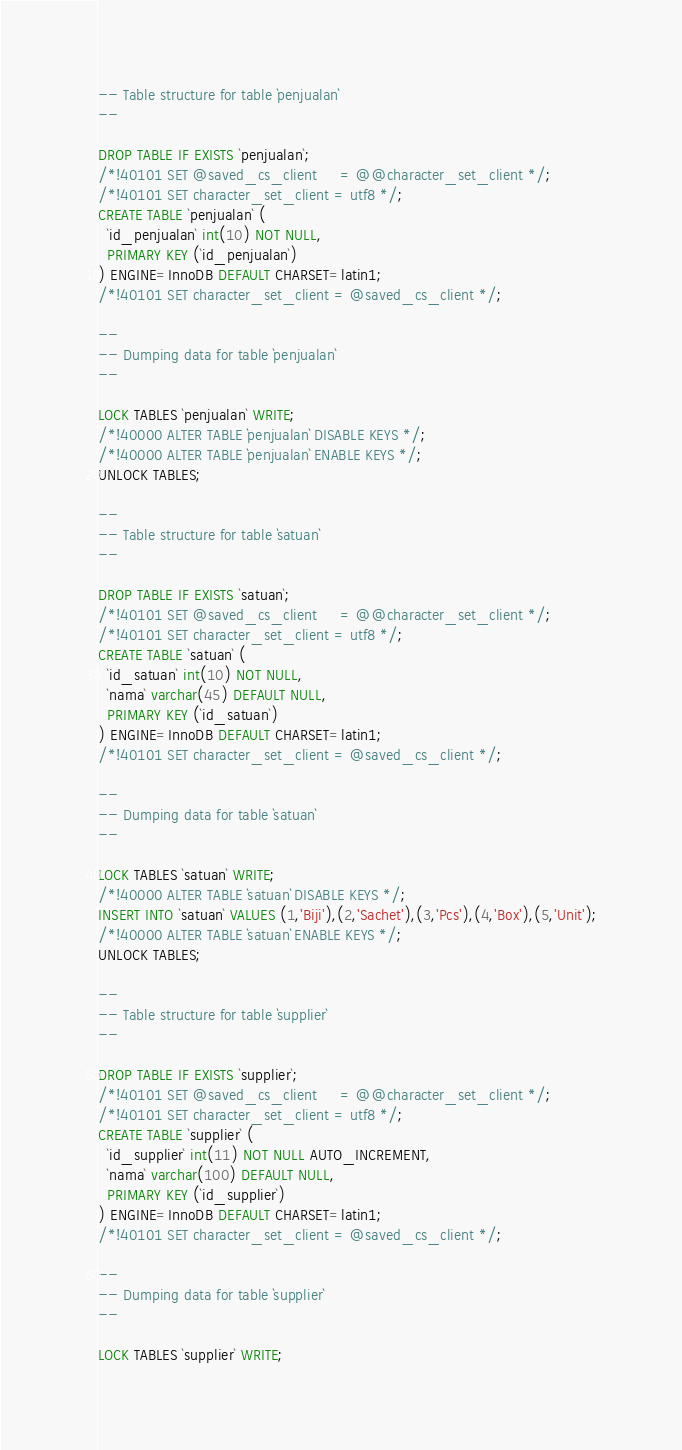<code> <loc_0><loc_0><loc_500><loc_500><_SQL_>-- Table structure for table `penjualan`
--

DROP TABLE IF EXISTS `penjualan`;
/*!40101 SET @saved_cs_client     = @@character_set_client */;
/*!40101 SET character_set_client = utf8 */;
CREATE TABLE `penjualan` (
  `id_penjualan` int(10) NOT NULL,
  PRIMARY KEY (`id_penjualan`)
) ENGINE=InnoDB DEFAULT CHARSET=latin1;
/*!40101 SET character_set_client = @saved_cs_client */;

--
-- Dumping data for table `penjualan`
--

LOCK TABLES `penjualan` WRITE;
/*!40000 ALTER TABLE `penjualan` DISABLE KEYS */;
/*!40000 ALTER TABLE `penjualan` ENABLE KEYS */;
UNLOCK TABLES;

--
-- Table structure for table `satuan`
--

DROP TABLE IF EXISTS `satuan`;
/*!40101 SET @saved_cs_client     = @@character_set_client */;
/*!40101 SET character_set_client = utf8 */;
CREATE TABLE `satuan` (
  `id_satuan` int(10) NOT NULL,
  `nama` varchar(45) DEFAULT NULL,
  PRIMARY KEY (`id_satuan`)
) ENGINE=InnoDB DEFAULT CHARSET=latin1;
/*!40101 SET character_set_client = @saved_cs_client */;

--
-- Dumping data for table `satuan`
--

LOCK TABLES `satuan` WRITE;
/*!40000 ALTER TABLE `satuan` DISABLE KEYS */;
INSERT INTO `satuan` VALUES (1,'Biji'),(2,'Sachet'),(3,'Pcs'),(4,'Box'),(5,'Unit');
/*!40000 ALTER TABLE `satuan` ENABLE KEYS */;
UNLOCK TABLES;

--
-- Table structure for table `supplier`
--

DROP TABLE IF EXISTS `supplier`;
/*!40101 SET @saved_cs_client     = @@character_set_client */;
/*!40101 SET character_set_client = utf8 */;
CREATE TABLE `supplier` (
  `id_supplier` int(11) NOT NULL AUTO_INCREMENT,
  `nama` varchar(100) DEFAULT NULL,
  PRIMARY KEY (`id_supplier`)
) ENGINE=InnoDB DEFAULT CHARSET=latin1;
/*!40101 SET character_set_client = @saved_cs_client */;

--
-- Dumping data for table `supplier`
--

LOCK TABLES `supplier` WRITE;</code> 